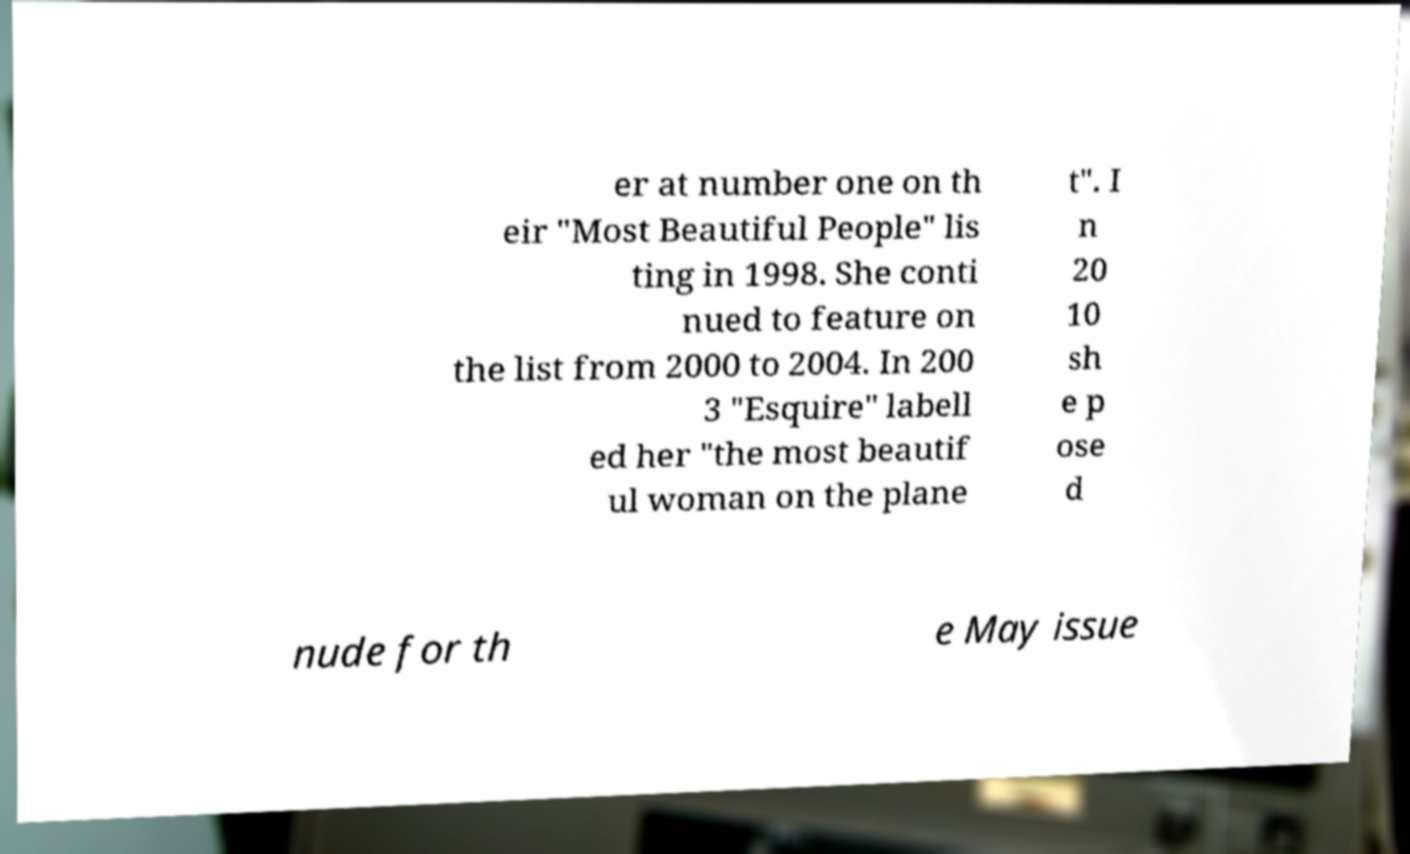What messages or text are displayed in this image? I need them in a readable, typed format. er at number one on th eir "Most Beautiful People" lis ting in 1998. She conti nued to feature on the list from 2000 to 2004. In 200 3 "Esquire" labell ed her "the most beautif ul woman on the plane t". I n 20 10 sh e p ose d nude for th e May issue 